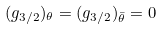<formula> <loc_0><loc_0><loc_500><loc_500>( g _ { 3 / 2 } ) _ { \theta } = ( g _ { 3 / 2 } ) _ { \bar { \theta } } = 0</formula> 